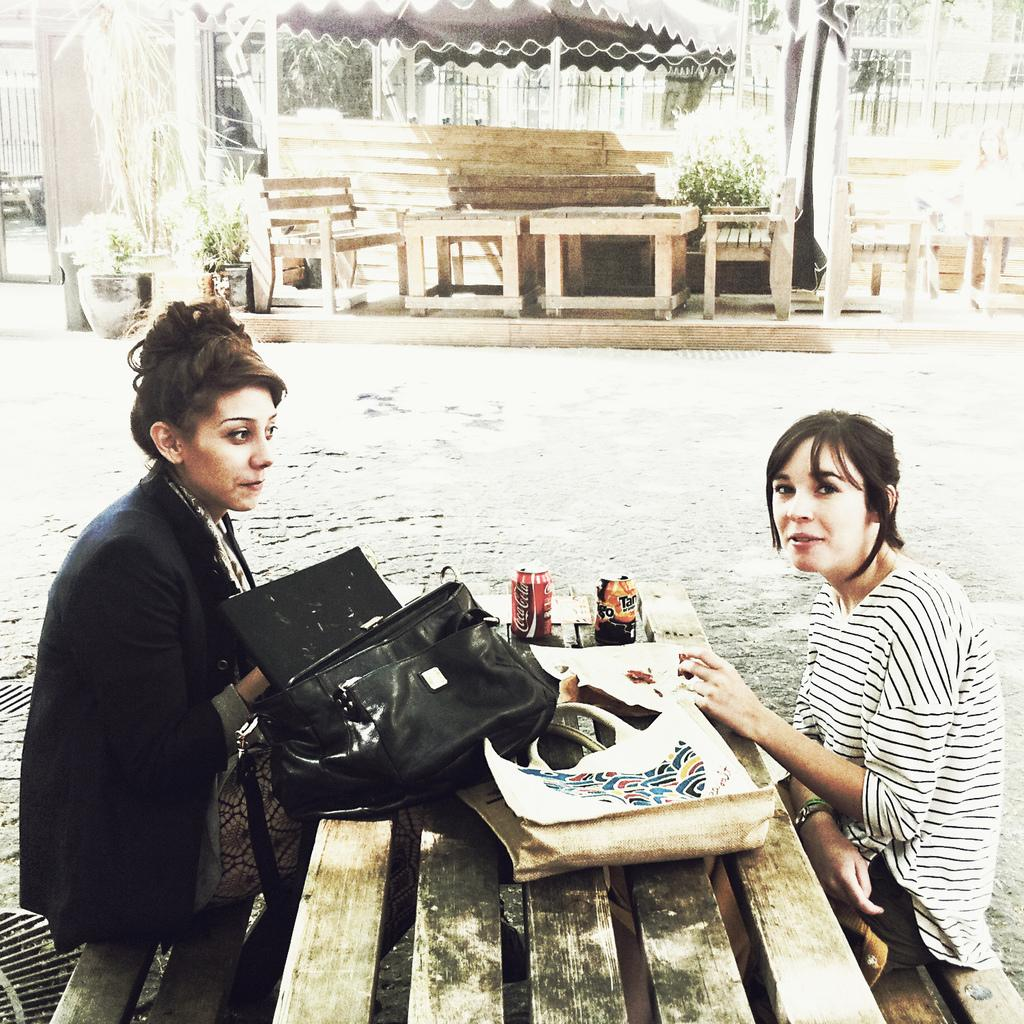How many women are in the image? There are two women in the image. What are the women doing in the image? The women are seated on a bench. What items can be seen in front of the women? There are bags and tins in front of the women. What can be seen in the background of the image? There are buildings and plants in the background of the image. What type of bird can be seen flying over the women in the image? There is no bird visible in the image. Is there a park bench where the women are seated in the image? The image does not specify whether the bench is located in a park or not. 